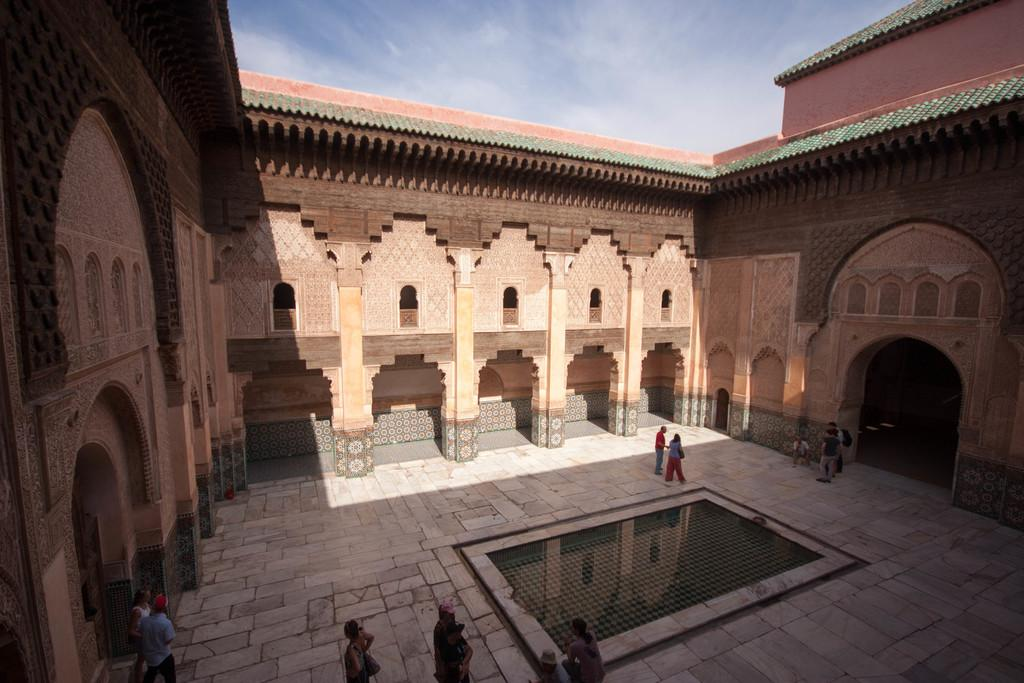How many people are in the image? There is a group of people in the image, but the exact number is not specified. What are the people in the image doing? The group of people is standing. What color is the building in the image? The building in the image is brown-colored. What colors can be seen in the sky in the background? The sky in the background is blue and white. How long does it take for the kite to fly in the image? There is no kite present in the image, so it is not possible to determine how long it would take for a kite to fly. 